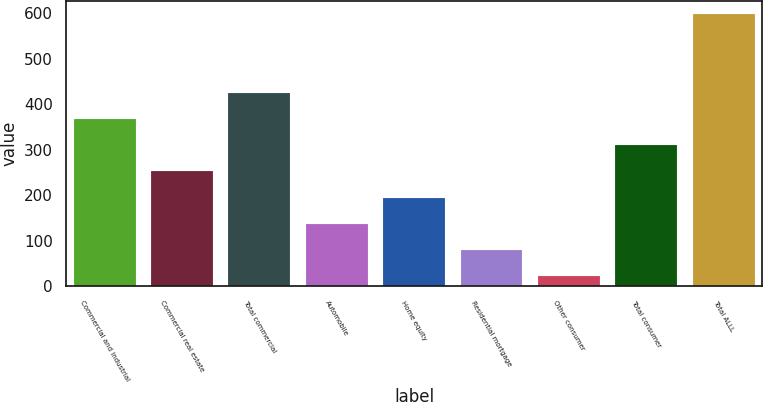Convert chart to OTSL. <chart><loc_0><loc_0><loc_500><loc_500><bar_chart><fcel>Commercial and industrial<fcel>Commercial real estate<fcel>Total commercial<fcel>Automobile<fcel>Home equity<fcel>Residential mortgage<fcel>Other consumer<fcel>Total consumer<fcel>Total ALLL<nl><fcel>368<fcel>253<fcel>425.5<fcel>138<fcel>195.5<fcel>80.5<fcel>23<fcel>310.5<fcel>598<nl></chart> 